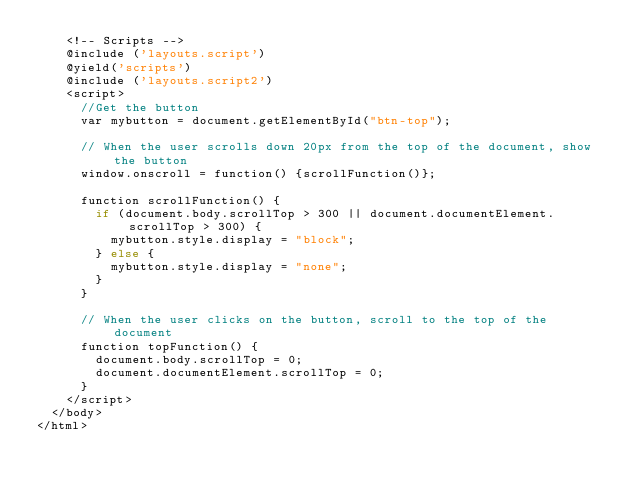Convert code to text. <code><loc_0><loc_0><loc_500><loc_500><_PHP_>    <!-- Scripts -->
    @include ('layouts.script')
    @yield('scripts')
    @include ('layouts.script2')
    <script>
      //Get the button
      var mybutton = document.getElementById("btn-top");

      // When the user scrolls down 20px from the top of the document, show the button
      window.onscroll = function() {scrollFunction()};

      function scrollFunction() {
        if (document.body.scrollTop > 300 || document.documentElement.scrollTop > 300) {
          mybutton.style.display = "block";
        } else {
          mybutton.style.display = "none";
        }
      }

      // When the user clicks on the button, scroll to the top of the document
      function topFunction() {
        document.body.scrollTop = 0;
        document.documentElement.scrollTop = 0;
      }
    </script>
  </body>
</html></code> 